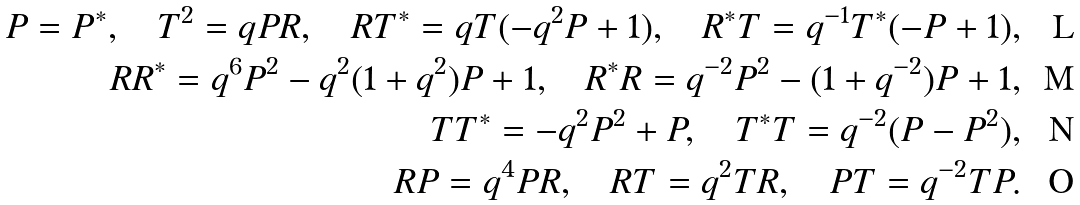<formula> <loc_0><loc_0><loc_500><loc_500>P = P ^ { * } , \quad T ^ { 2 } = q P R , \quad R T ^ { * } = q T ( - q ^ { 2 } P + 1 ) , \quad R ^ { * } T = q ^ { - 1 } T ^ { * } ( - P + 1 ) , \\ R R ^ { * } = q ^ { 6 } P ^ { 2 } - q ^ { 2 } ( 1 + q ^ { 2 } ) P + 1 , \quad R ^ { * } R = q ^ { - 2 } P ^ { 2 } - ( 1 + q ^ { - 2 } ) P + 1 , \\ T T ^ { * } = - q ^ { 2 } P ^ { 2 } + P , \quad T ^ { * } T = q ^ { - 2 } ( P - P ^ { 2 } ) , \\ R P = q ^ { 4 } P R , \quad R T = q ^ { 2 } T R , \quad P T = q ^ { - 2 } T P .</formula> 